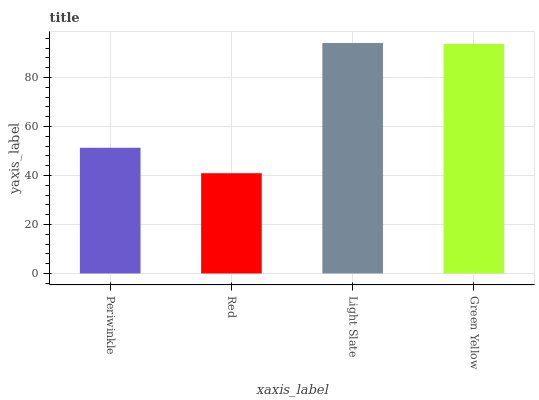Is Red the minimum?
Answer yes or no. Yes. Is Light Slate the maximum?
Answer yes or no. Yes. Is Light Slate the minimum?
Answer yes or no. No. Is Red the maximum?
Answer yes or no. No. Is Light Slate greater than Red?
Answer yes or no. Yes. Is Red less than Light Slate?
Answer yes or no. Yes. Is Red greater than Light Slate?
Answer yes or no. No. Is Light Slate less than Red?
Answer yes or no. No. Is Green Yellow the high median?
Answer yes or no. Yes. Is Periwinkle the low median?
Answer yes or no. Yes. Is Light Slate the high median?
Answer yes or no. No. Is Green Yellow the low median?
Answer yes or no. No. 